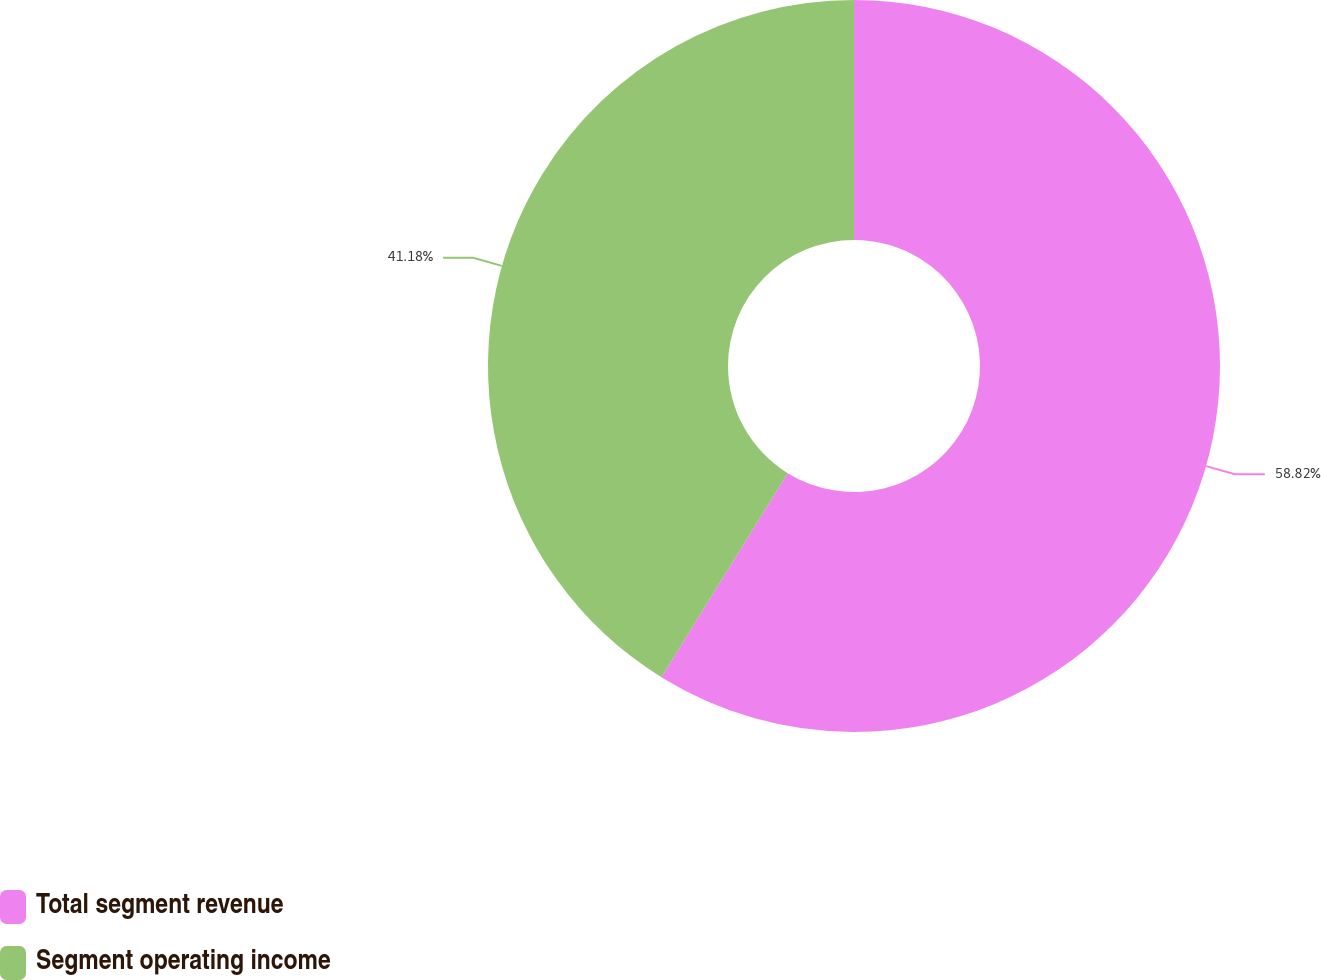Convert chart. <chart><loc_0><loc_0><loc_500><loc_500><pie_chart><fcel>Total segment revenue<fcel>Segment operating income<nl><fcel>58.82%<fcel>41.18%<nl></chart> 